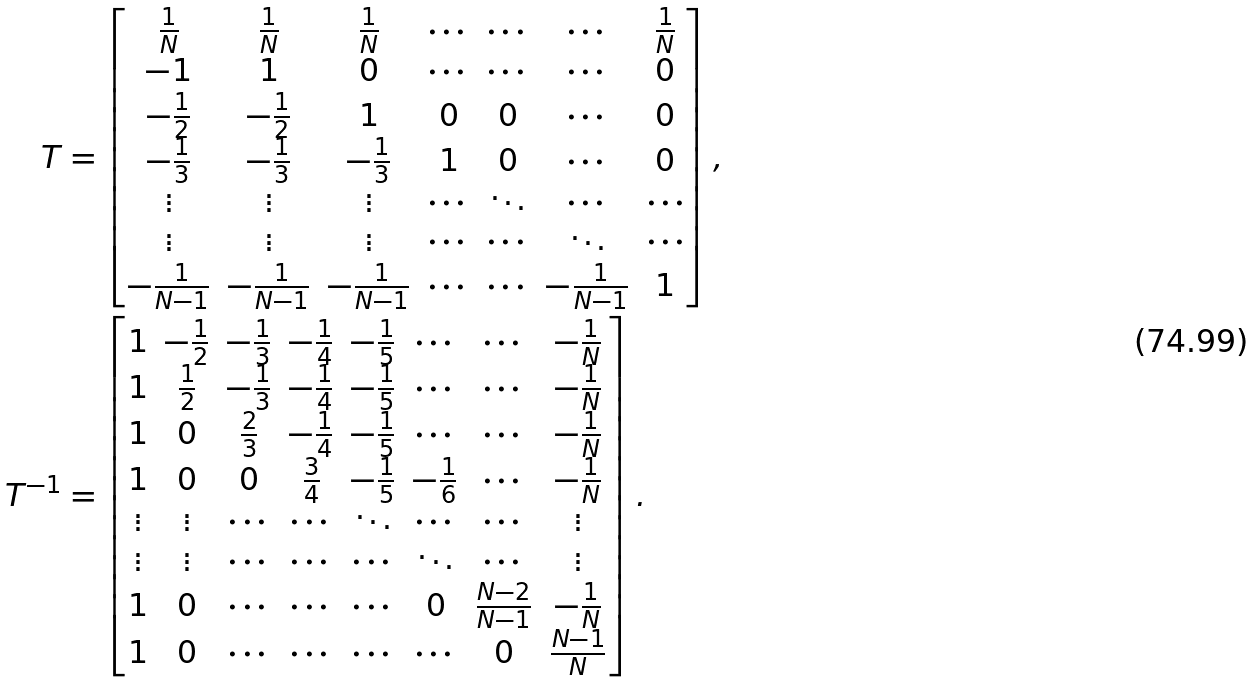<formula> <loc_0><loc_0><loc_500><loc_500>T & = \begin{bmatrix} \frac { 1 } { N } & \frac { 1 } { N } & \frac { 1 } { N } & \cdots & \cdots & \cdots & \frac { 1 } { N } \\ - 1 & 1 & 0 & \cdots & \cdots & \cdots & 0 \\ - \frac { 1 } { 2 } & - \frac { 1 } { 2 } & 1 & 0 & 0 & \cdots & 0 \\ - \frac { 1 } { 3 } & - \frac { 1 } { 3 } & - \frac { 1 } { 3 } & 1 & 0 & \cdots & 0 \\ \vdots & \vdots & \vdots & \cdots & \ddots & \cdots & \cdots \\ \vdots & \vdots & \vdots & \cdots & \cdots & \ddots & \cdots \\ - \frac { 1 } { N - 1 } & - \frac { 1 } { N - 1 } & - \frac { 1 } { N - 1 } & \cdots & \cdots & - \frac { 1 } { N - 1 } & 1 \end{bmatrix} , \\ T ^ { - 1 } & = \begin{bmatrix} 1 & - \frac { 1 } { 2 } & - \frac { 1 } { 3 } & - \frac { 1 } { 4 } & - \frac { 1 } { 5 } & \cdots & \cdots & - \frac { 1 } { N } \\ 1 & \frac { 1 } { 2 } & - \frac { 1 } { 3 } & - \frac { 1 } { 4 } & - \frac { 1 } { 5 } & \cdots & \cdots & - \frac { 1 } { N } \\ 1 & 0 & \frac { 2 } { 3 } & - \frac { 1 } { 4 } & - \frac { 1 } { 5 } & \cdots & \cdots & - \frac { 1 } { N } \\ 1 & 0 & 0 & \frac { 3 } { 4 } & - \frac { 1 } { 5 } & - \frac { 1 } { 6 } & \cdots & - \frac { 1 } { N } \\ \vdots & \vdots & \cdots & \cdots & \ddots & \cdots & \cdots & \vdots \\ \vdots & \vdots & \cdots & \cdots & \cdots & \ddots & \cdots & \vdots \\ 1 & 0 & \cdots & \cdots & \cdots & 0 & \frac { N - 2 } { N - 1 } & - \frac { 1 } { N } \\ 1 & 0 & \cdots & \cdots & \cdots & \cdots & 0 & \frac { N - 1 } { N } \end{bmatrix} .</formula> 